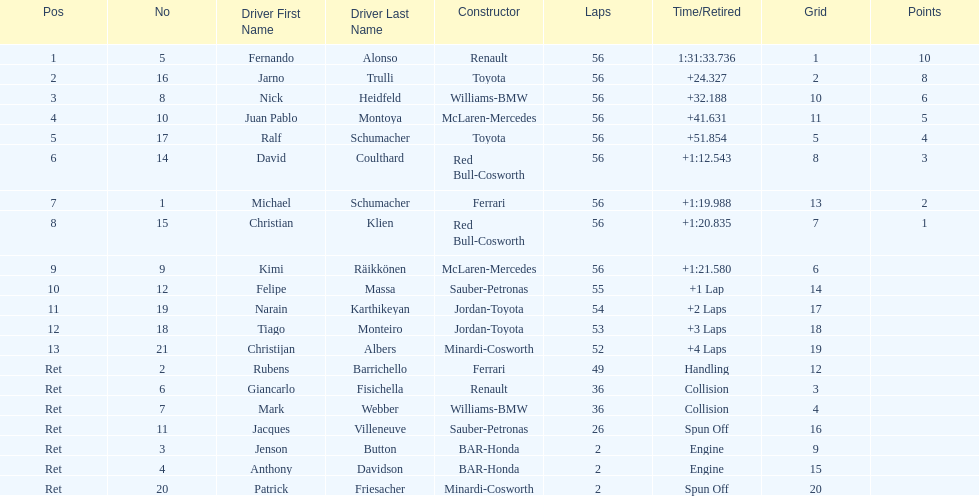How many germans finished in the top five? 2. 